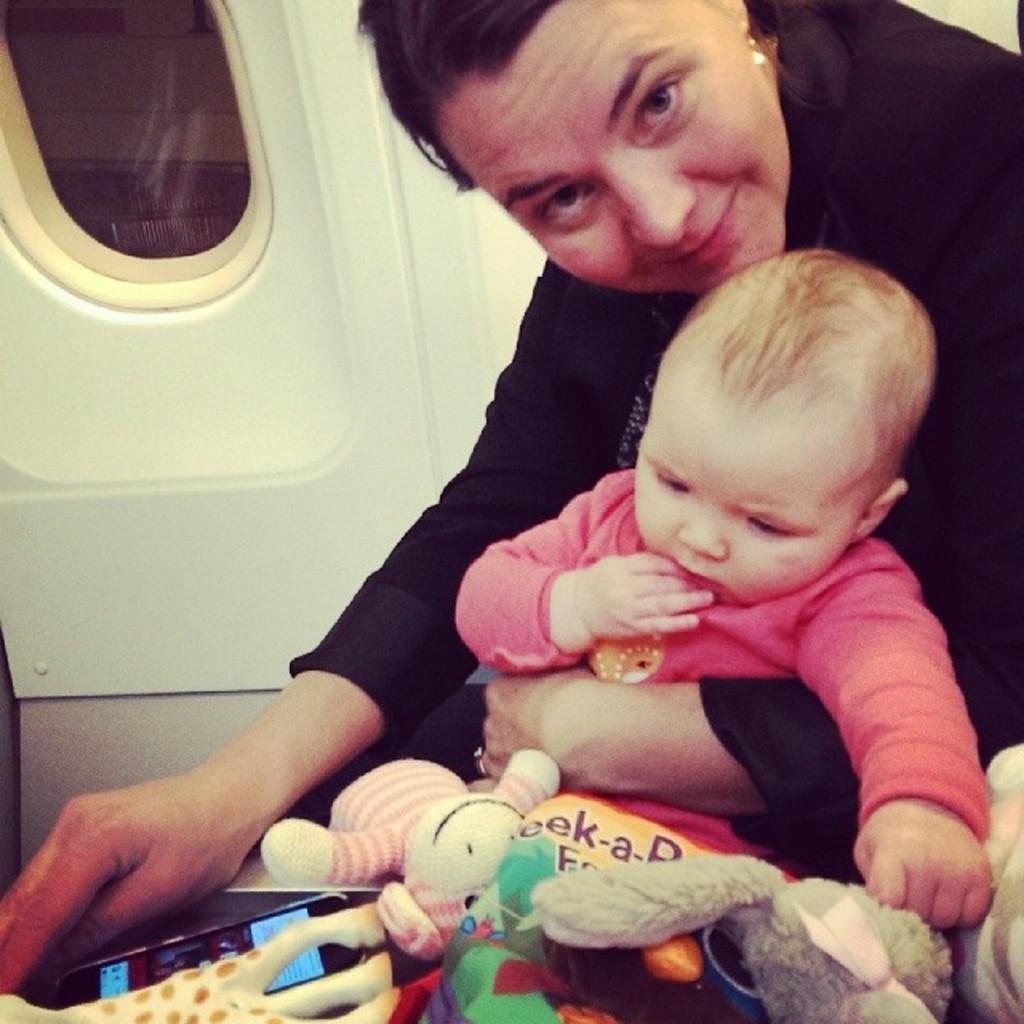Can you describe this image briefly? In this picture there is an lady on the right side of the image and there is a small baby on her laps, there are toys and a phone at the bottom side of the image and there is a window in the top left side of the image. 